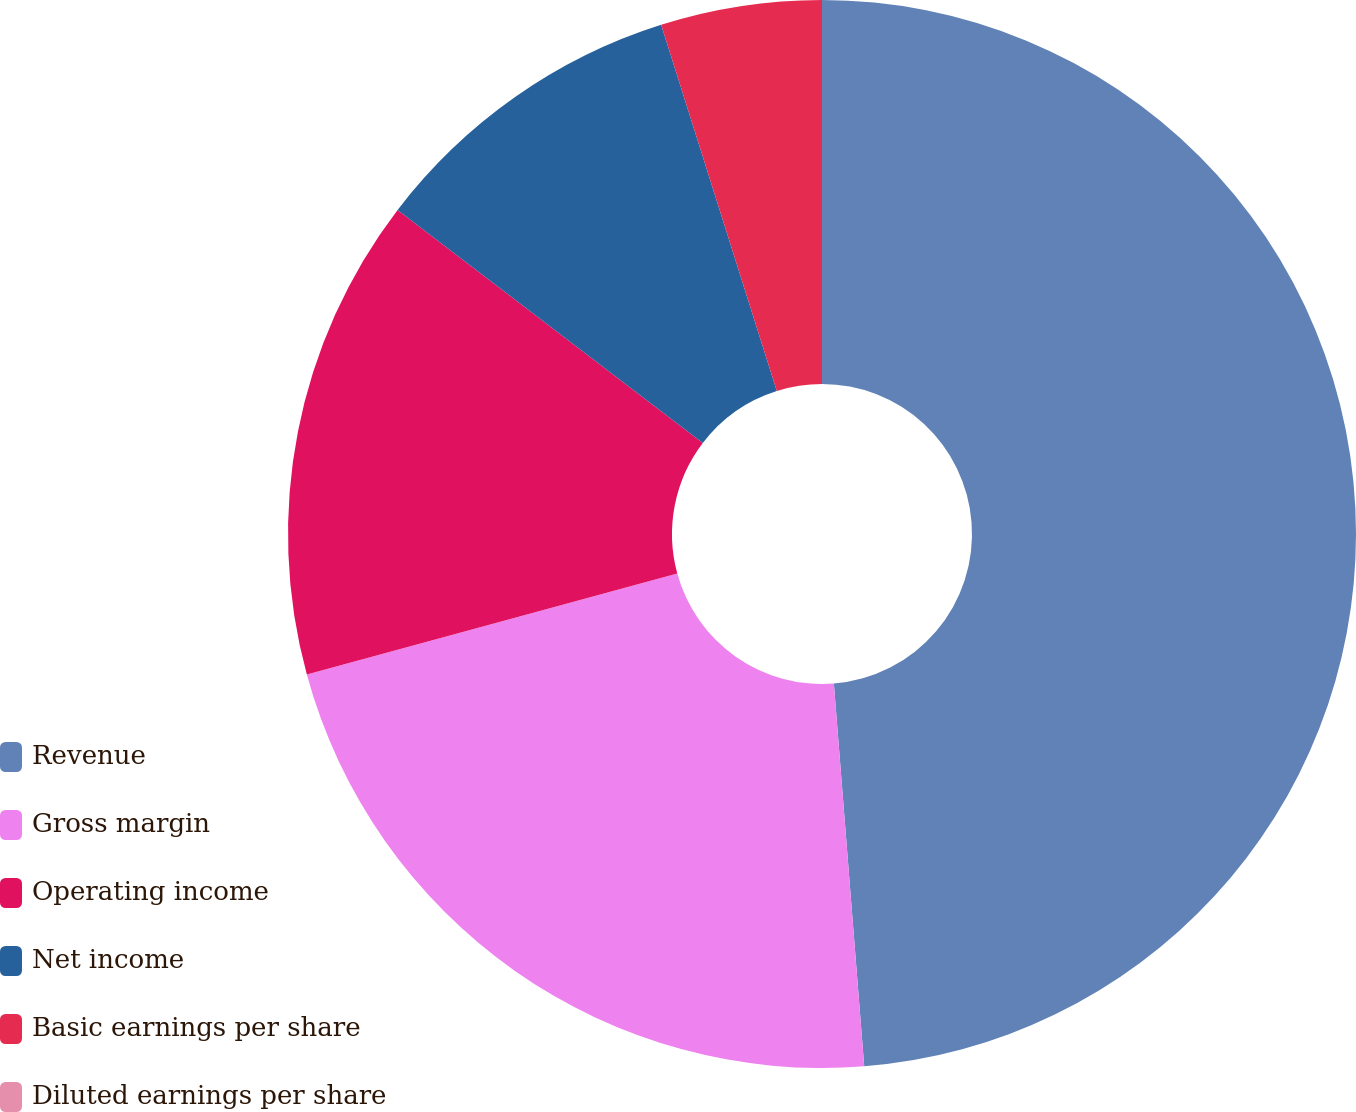Convert chart. <chart><loc_0><loc_0><loc_500><loc_500><pie_chart><fcel>Revenue<fcel>Gross margin<fcel>Operating income<fcel>Net income<fcel>Basic earnings per share<fcel>Diluted earnings per share<nl><fcel>48.74%<fcel>22.02%<fcel>14.62%<fcel>9.75%<fcel>4.87%<fcel>0.0%<nl></chart> 